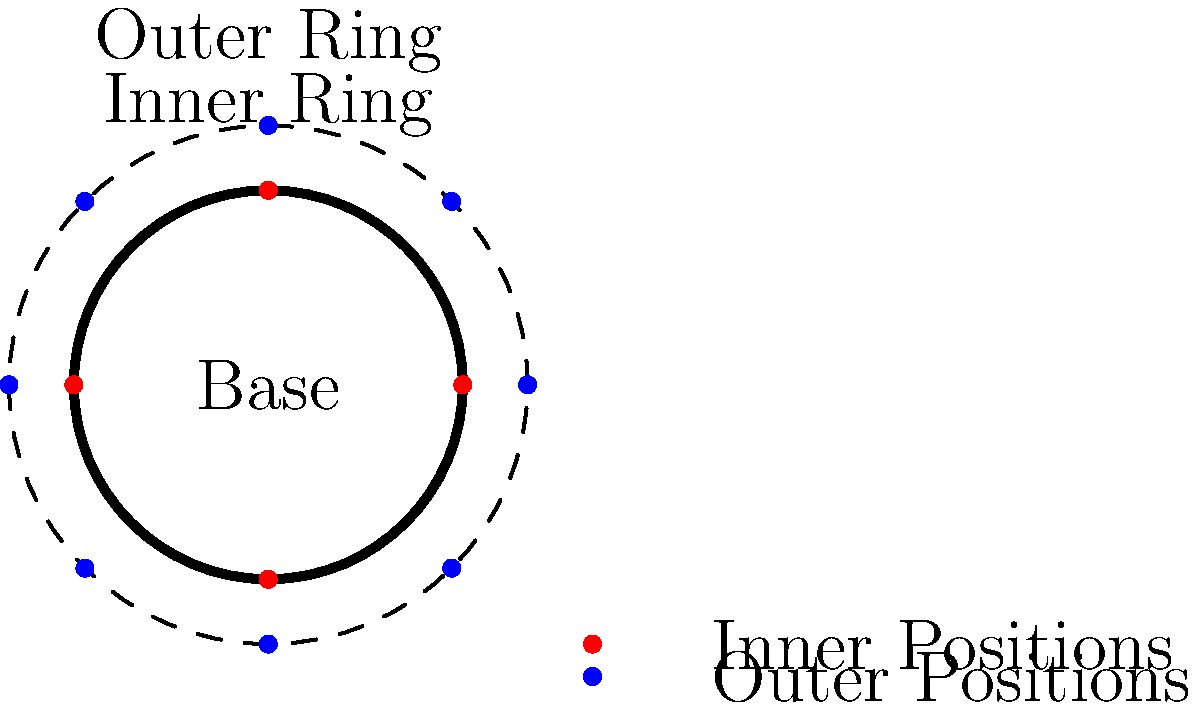In designing the optimal layout for defensive fortifications of a BattleMech base, you've proposed a circular design with two defensive rings. The inner ring has 4 equally spaced positions, while the outer ring has 8. If each inner position can effectively cover an arc of 120° and each outer position can cover 60°, what is the minimum number of positions that need to be manned to ensure complete 360° coverage of the base? Let's approach this step-by-step:

1. Inner ring coverage:
   - Each inner position covers 120°
   - Total coverage by 4 positions: $4 \times 120° = 480°$
   - This exceeds 360°, so we don't necessarily need all inner positions manned

2. Outer ring coverage:
   - Each outer position covers 60°
   - Total coverage by 8 positions: $8 \times 60° = 480°$
   - Again, this exceeds 360°

3. Optimal coverage strategy:
   - Start with inner positions as they cover more area each
   - Three inner positions cover: $3 \times 120° = 360°$
   - This provides complete coverage

4. Verification:
   - Using 3 inner positions leaves a 60° gap
   - This gap can be covered by 1 outer position

5. Alternative strategy:
   - Use 2 inner positions: $2 \times 120° = 240°$
   - Cover remaining 120° with 2 outer positions: $2 \times 60° = 120°$
   - Total: 2 inner + 2 outer = 4 positions

6. Conclusion:
   - Both strategies (3 inner or 2 inner + 2 outer) use 4 positions
   - 4 is the minimum number to ensure complete coverage

Therefore, the minimum number of positions that need to be manned is 4.
Answer: 4 positions 